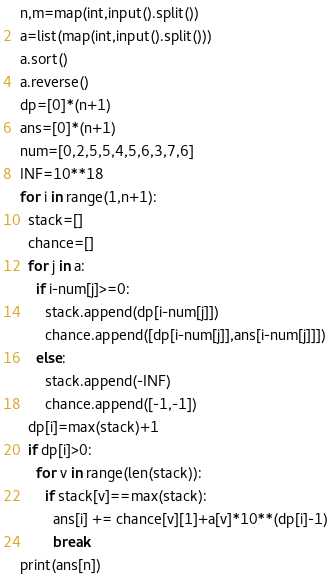<code> <loc_0><loc_0><loc_500><loc_500><_Python_>n,m=map(int,input().split())
a=list(map(int,input().split()))
a.sort()
a.reverse()
dp=[0]*(n+1)
ans=[0]*(n+1)
num=[0,2,5,5,4,5,6,3,7,6]
INF=10**18
for i in range(1,n+1):
  stack=[]
  chance=[]
  for j in a:
    if i-num[j]>=0:
      stack.append(dp[i-num[j]])
      chance.append([dp[i-num[j]],ans[i-num[j]]])
    else:
      stack.append(-INF)
      chance.append([-1,-1])
  dp[i]=max(stack)+1
  if dp[i]>0:
    for v in range(len(stack)):
      if stack[v]==max(stack):
        ans[i] += chance[v][1]+a[v]*10**(dp[i]-1)
        break
print(ans[n])</code> 